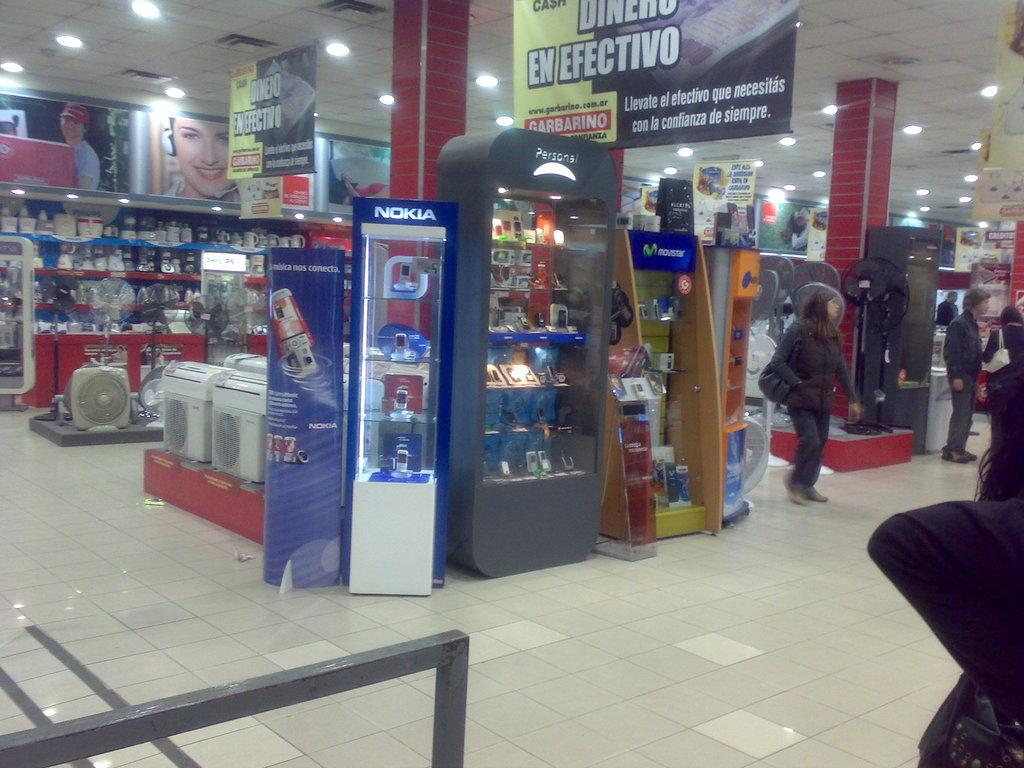Where was the image taken? The image was taken inside a store. What type of products can be found in the store? There are mobile phones, coolers, fans, and other electrical items in the store. Are there any people present in the image? Yes, there are people standing in the store. Can you see any bikes or geese in the store? No, there are no bikes or geese present in the image. What type of clouds can be seen through the store's windows? There are no windows visible in the image, and therefore no clouds can be seen. 